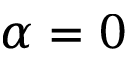Convert formula to latex. <formula><loc_0><loc_0><loc_500><loc_500>\alpha = 0</formula> 